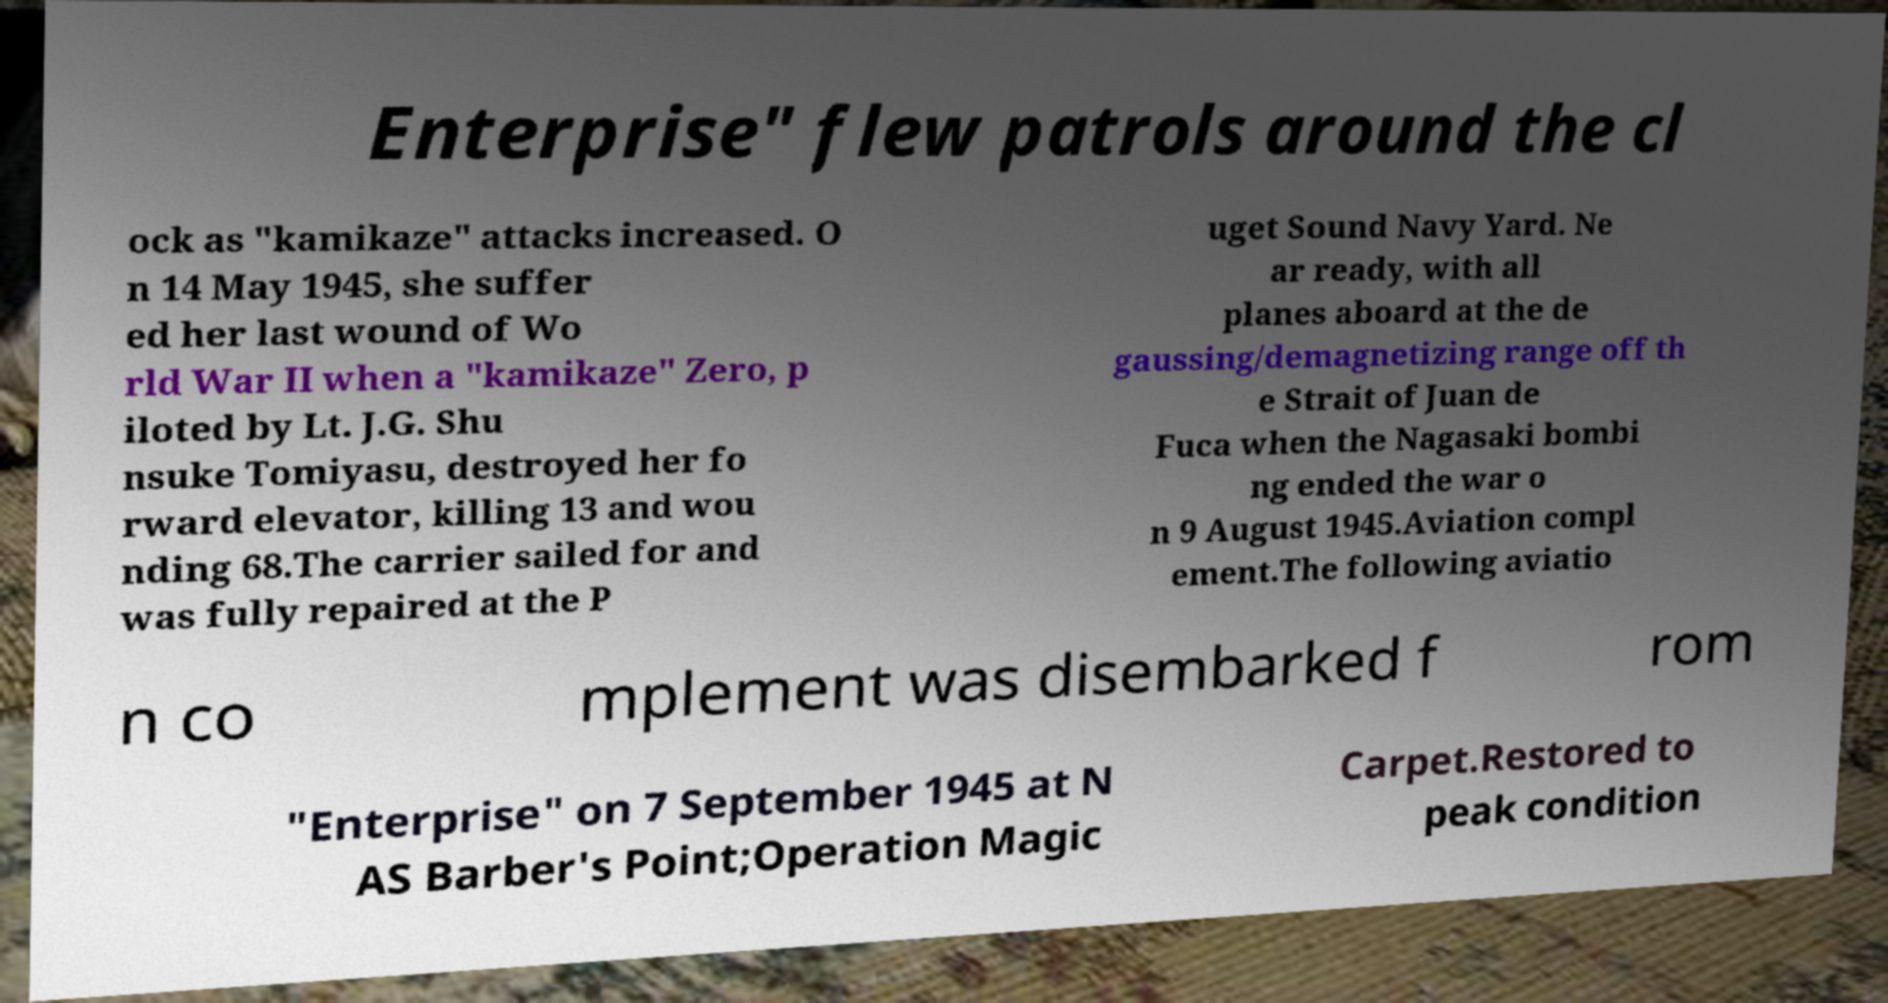Could you assist in decoding the text presented in this image and type it out clearly? Enterprise" flew patrols around the cl ock as "kamikaze" attacks increased. O n 14 May 1945, she suffer ed her last wound of Wo rld War II when a "kamikaze" Zero, p iloted by Lt. J.G. Shu nsuke Tomiyasu, destroyed her fo rward elevator, killing 13 and wou nding 68.The carrier sailed for and was fully repaired at the P uget Sound Navy Yard. Ne ar ready, with all planes aboard at the de gaussing/demagnetizing range off th e Strait of Juan de Fuca when the Nagasaki bombi ng ended the war o n 9 August 1945.Aviation compl ement.The following aviatio n co mplement was disembarked f rom "Enterprise" on 7 September 1945 at N AS Barber's Point;Operation Magic Carpet.Restored to peak condition 